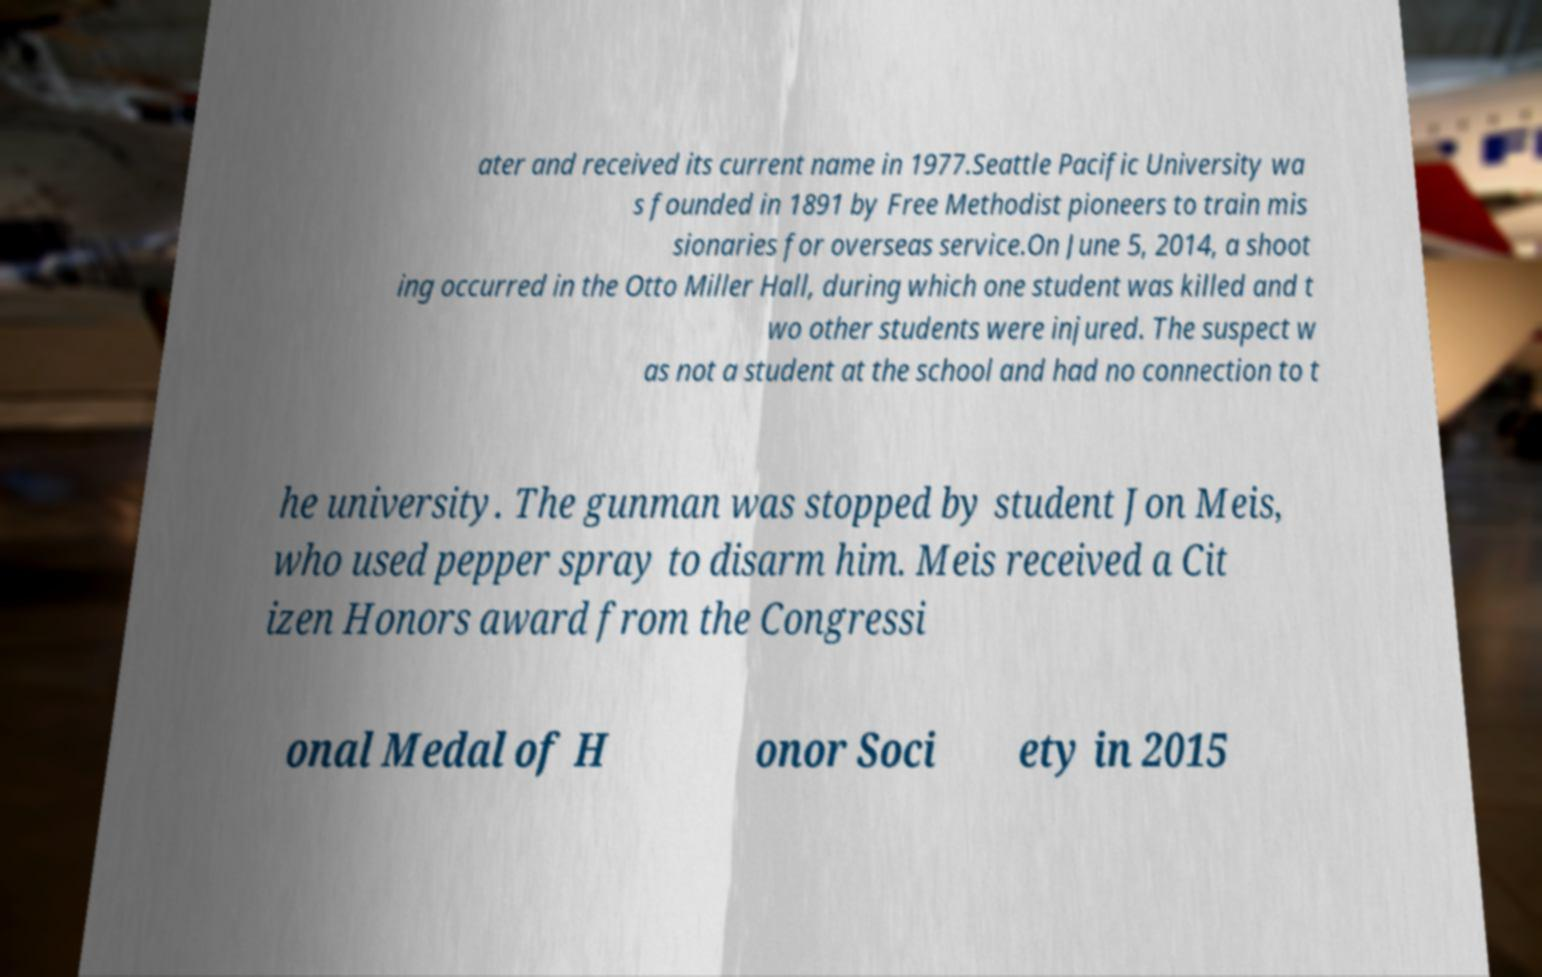Could you assist in decoding the text presented in this image and type it out clearly? ater and received its current name in 1977.Seattle Pacific University wa s founded in 1891 by Free Methodist pioneers to train mis sionaries for overseas service.On June 5, 2014, a shoot ing occurred in the Otto Miller Hall, during which one student was killed and t wo other students were injured. The suspect w as not a student at the school and had no connection to t he university. The gunman was stopped by student Jon Meis, who used pepper spray to disarm him. Meis received a Cit izen Honors award from the Congressi onal Medal of H onor Soci ety in 2015 